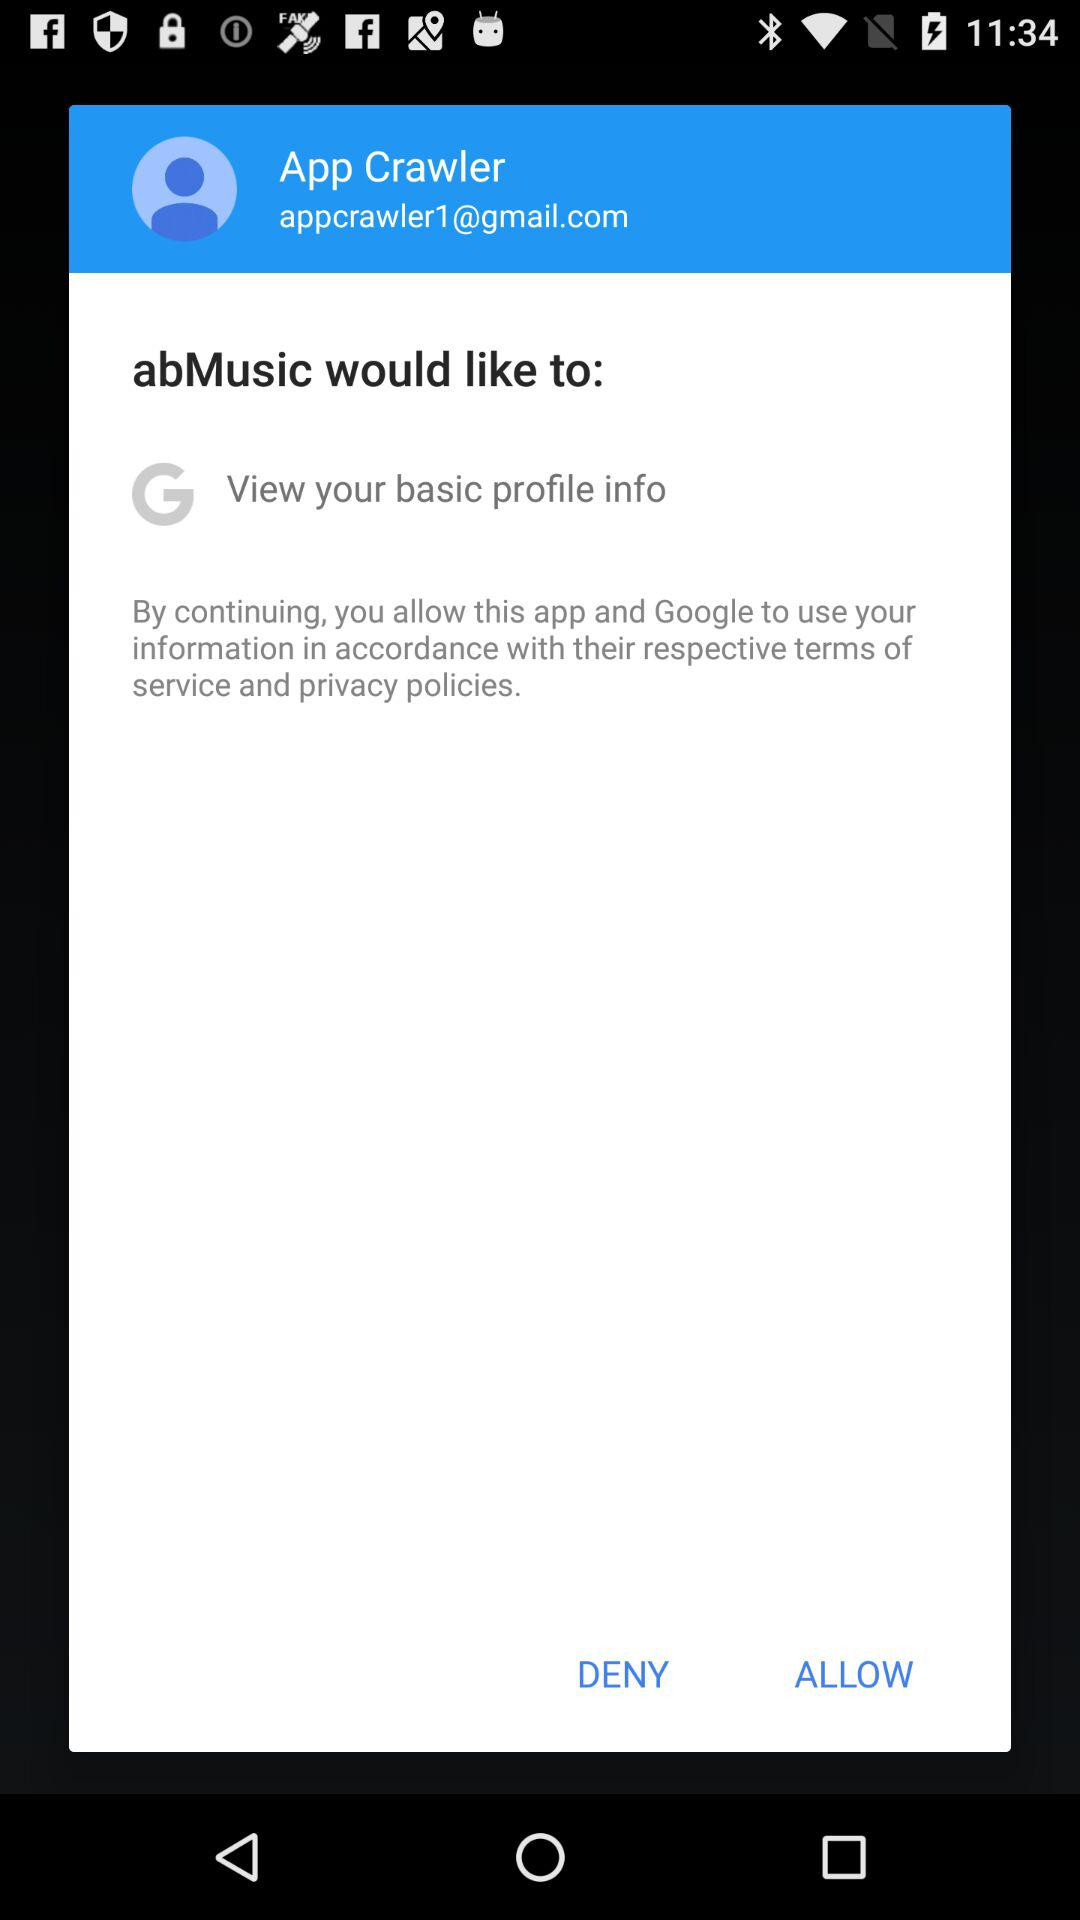What is the email address? The email address is appcrawler1@gmail.com. 